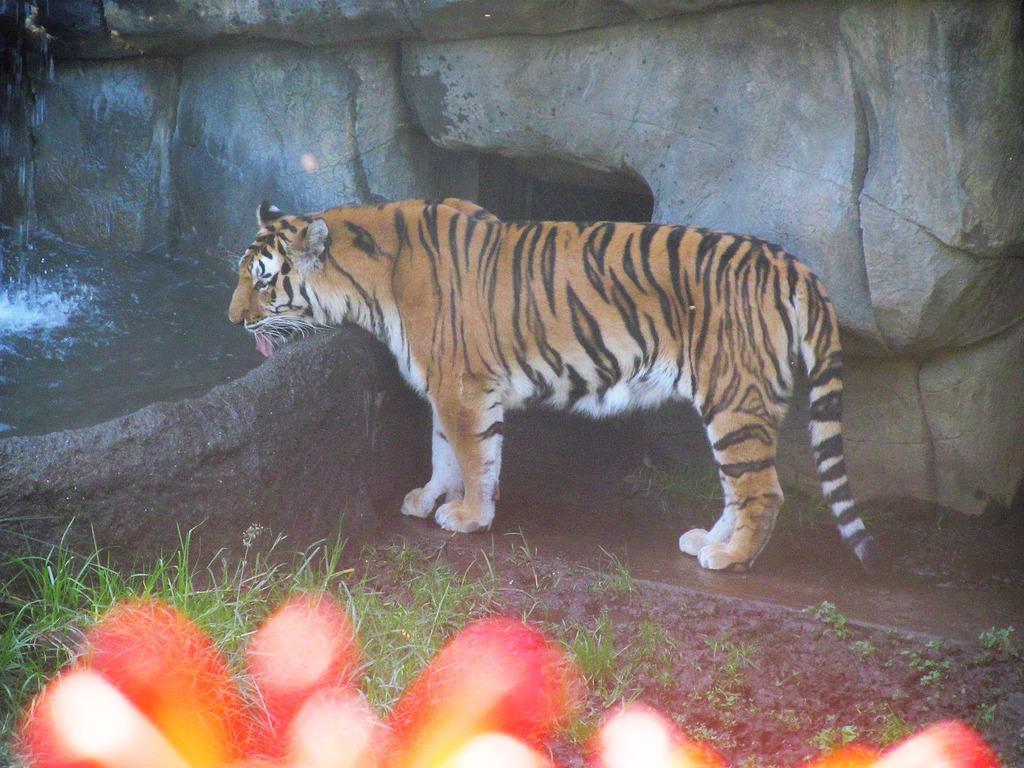Please provide a concise description of this image. In this image we can see a tiger. There is water on the left side of the image. At the bottom of the image, we can see grass on the land. There is a rock wall in the background of the image. 